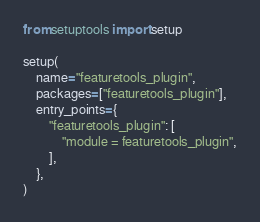Convert code to text. <code><loc_0><loc_0><loc_500><loc_500><_Python_>from setuptools import setup

setup(
    name="featuretools_plugin",
    packages=["featuretools_plugin"],
    entry_points={
        "featuretools_plugin": [
            "module = featuretools_plugin",
        ],
    },
)
</code> 